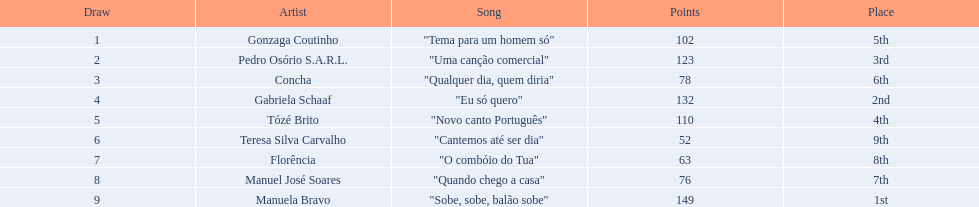Parse the table in full. {'header': ['Draw', 'Artist', 'Song', 'Points', 'Place'], 'rows': [['1', 'Gonzaga Coutinho', '"Tema para um homem só"', '102', '5th'], ['2', 'Pedro Osório S.A.R.L.', '"Uma canção comercial"', '123', '3rd'], ['3', 'Concha', '"Qualquer dia, quem diria"', '78', '6th'], ['4', 'Gabriela Schaaf', '"Eu só quero"', '132', '2nd'], ['5', 'Tózé Brito', '"Novo canto Português"', '110', '4th'], ['6', 'Teresa Silva Carvalho', '"Cantemos até ser dia"', '52', '9th'], ['7', 'Florência', '"O combóio do Tua"', '63', '8th'], ['8', 'Manuel José Soares', '"Quando chego a casa"', '76', '7th'], ['9', 'Manuela Bravo', '"Sobe, sobe, balão sobe"', '149', '1st']]} Which artists sang in the eurovision song contest of 1979? Gonzaga Coutinho, Pedro Osório S.A.R.L., Concha, Gabriela Schaaf, Tózé Brito, Teresa Silva Carvalho, Florência, Manuel José Soares, Manuela Bravo. Of these, who sang eu so quero? Gabriela Schaaf. 